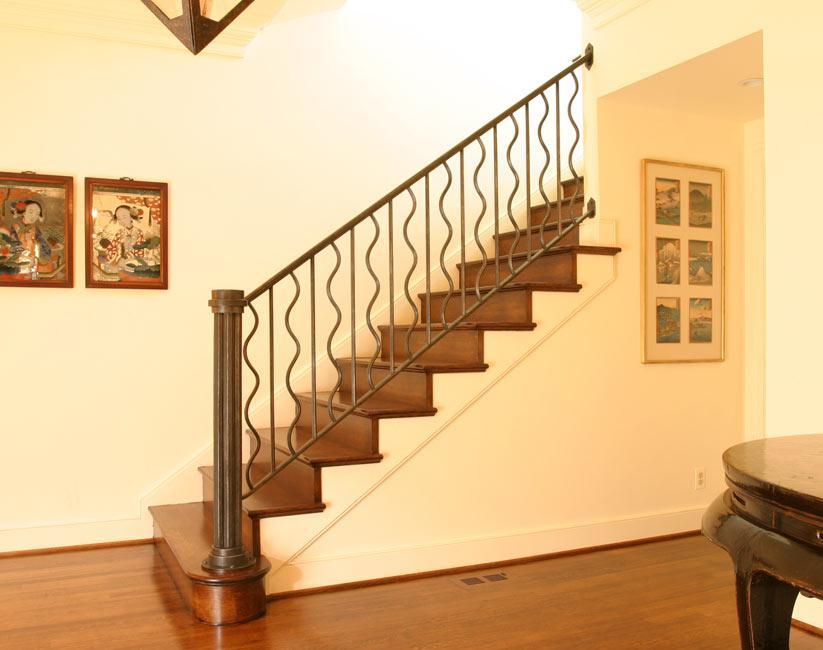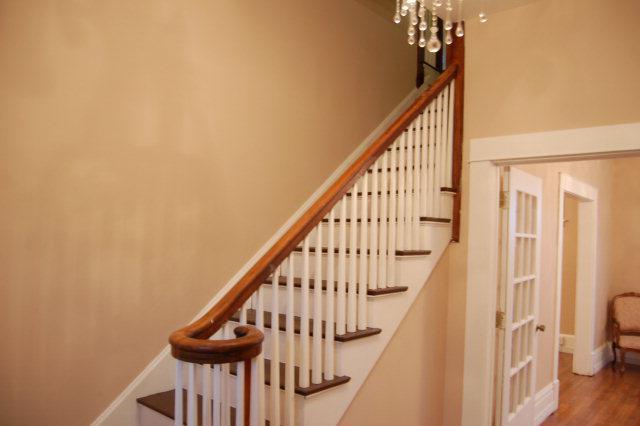The first image is the image on the left, the second image is the image on the right. Evaluate the accuracy of this statement regarding the images: "The right image shows a gate with vertical bars mounted to posts on each side to protect from falls, and a set of stairs is visible in the image.". Is it true? Answer yes or no. No. 